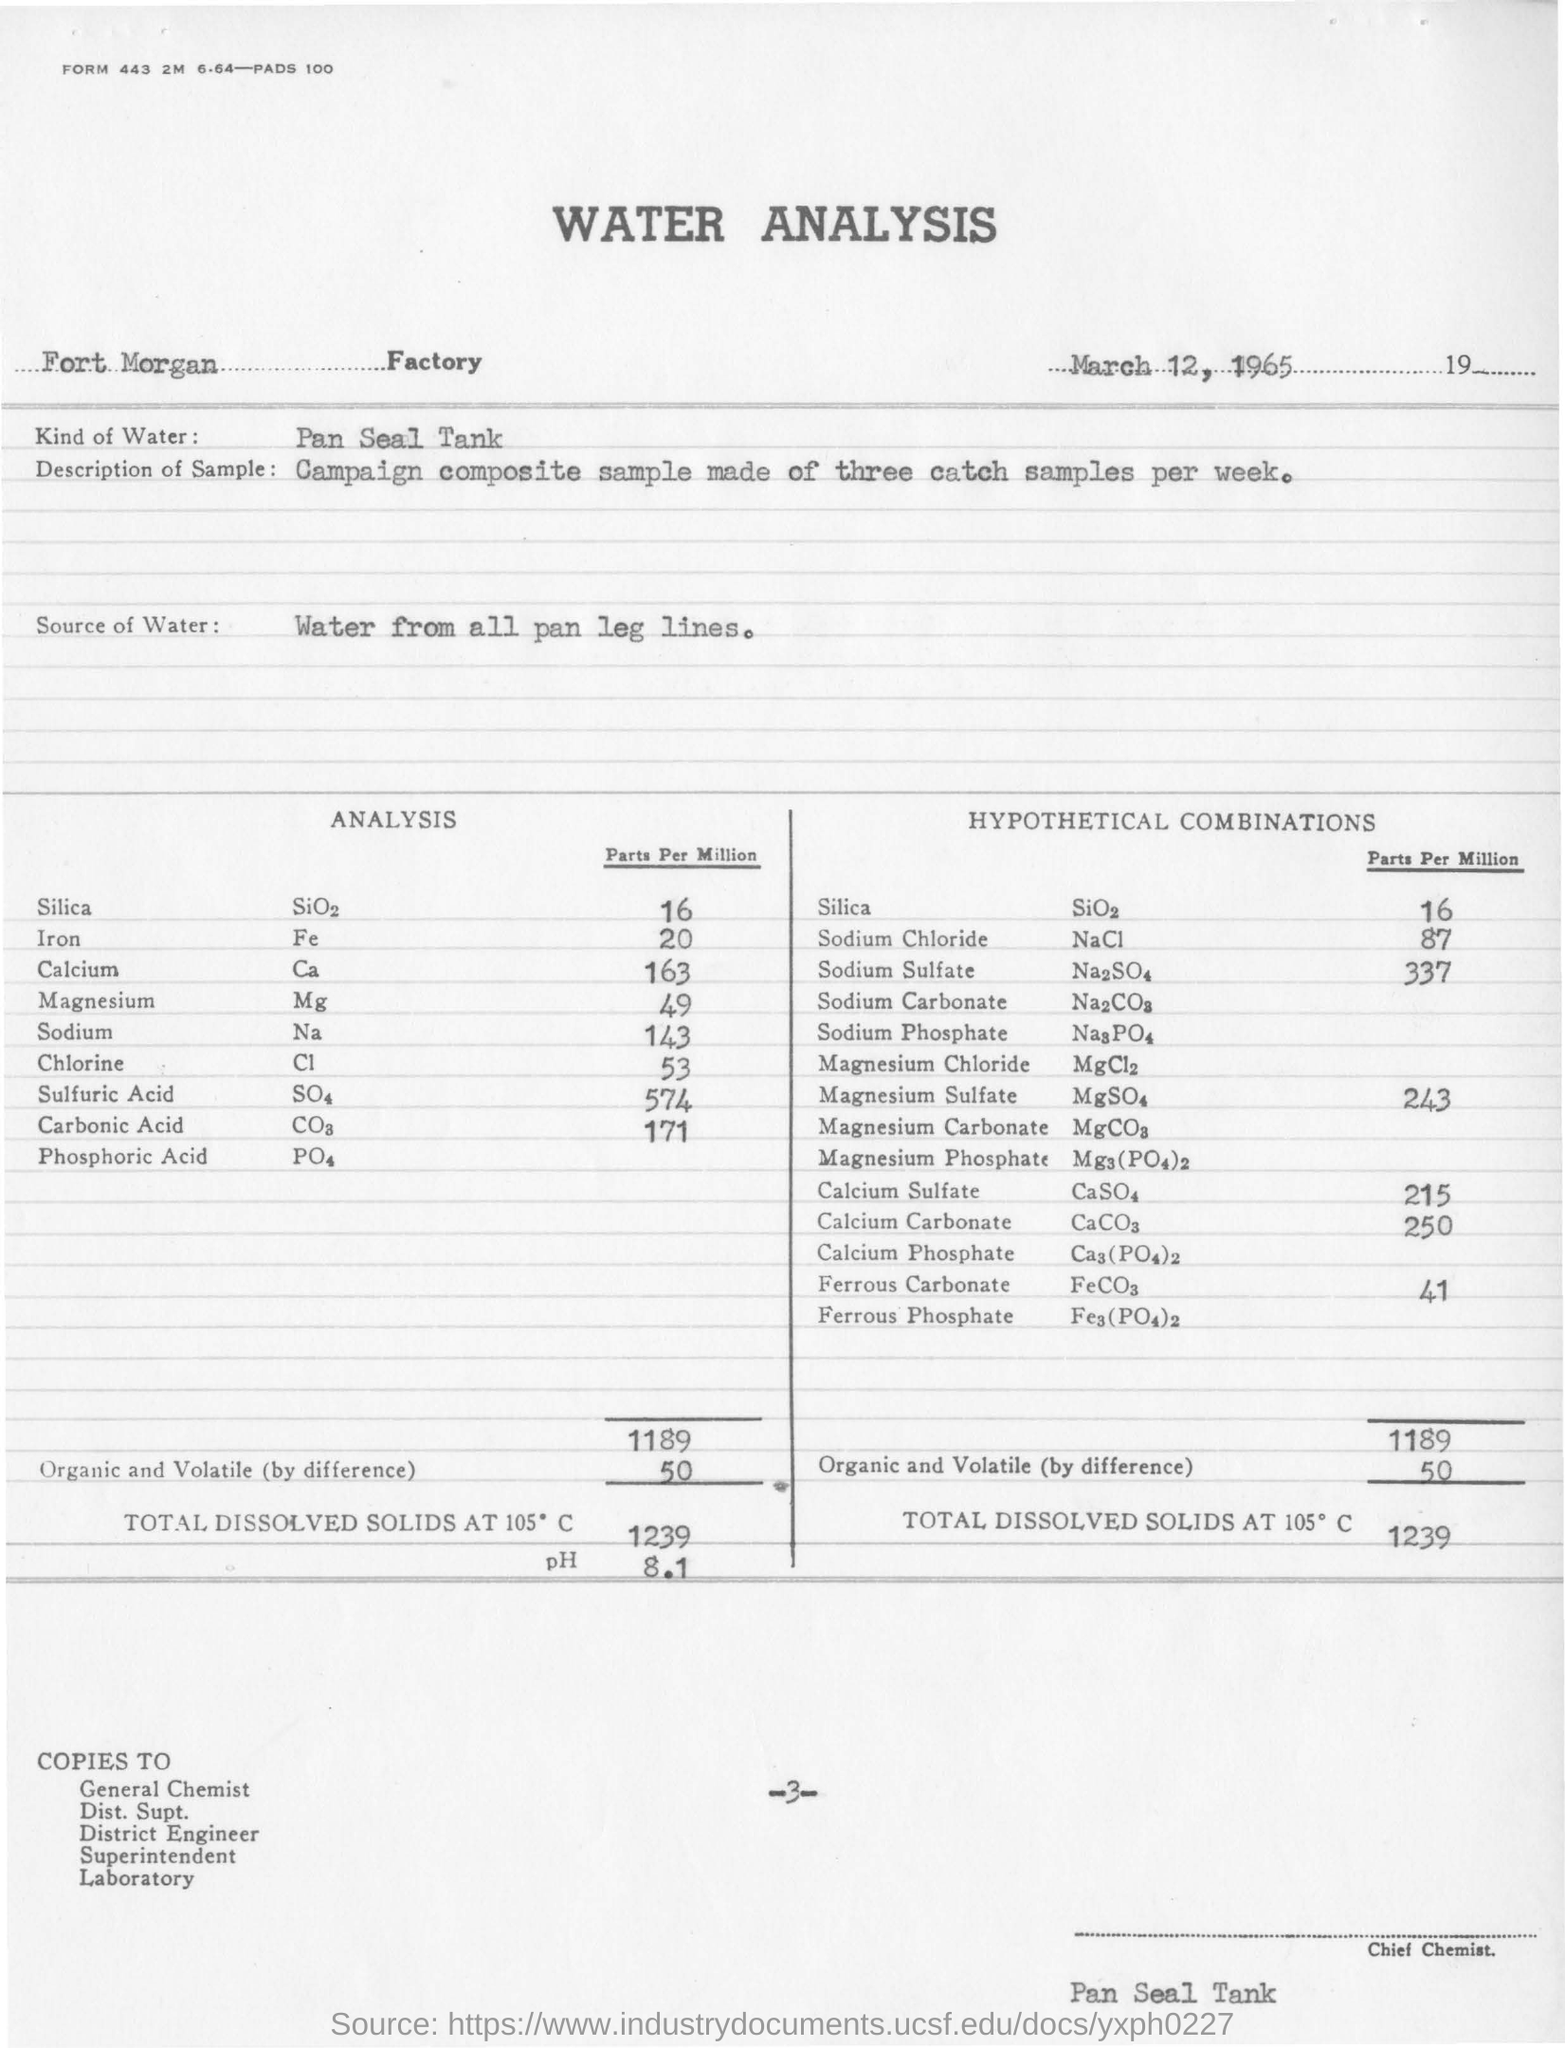Specify some key components in this picture. The analysis is dated March 12, 1965. I have determined that the factory in question is named Fort Morgan Factory. 